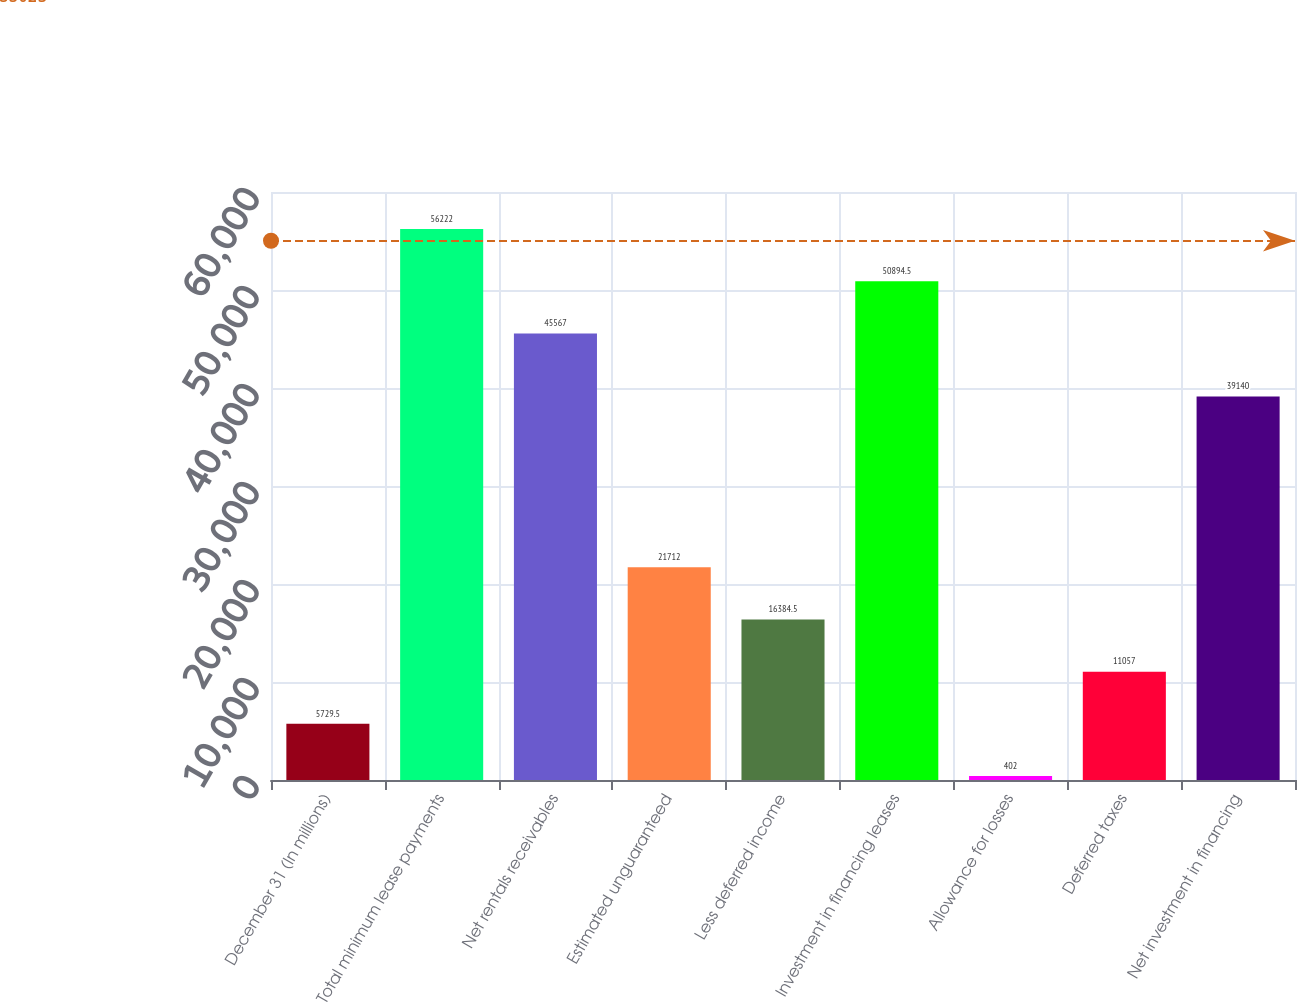Convert chart. <chart><loc_0><loc_0><loc_500><loc_500><bar_chart><fcel>December 31 (In millions)<fcel>Total minimum lease payments<fcel>Net rentals receivables<fcel>Estimated unguaranteed<fcel>Less deferred income<fcel>Investment in financing leases<fcel>Allowance for losses<fcel>Deferred taxes<fcel>Net investment in financing<nl><fcel>5729.5<fcel>56222<fcel>45567<fcel>21712<fcel>16384.5<fcel>50894.5<fcel>402<fcel>11057<fcel>39140<nl></chart> 